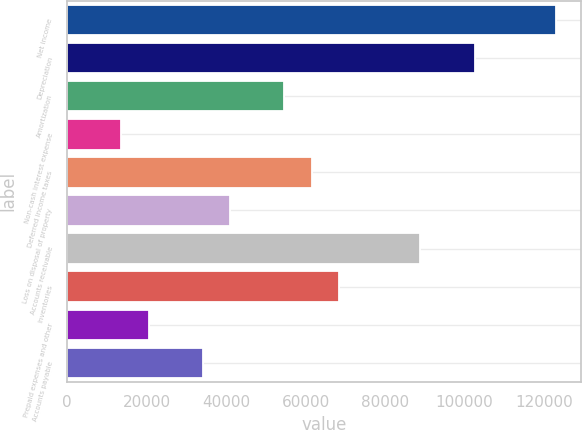Convert chart. <chart><loc_0><loc_0><loc_500><loc_500><bar_chart><fcel>Net income<fcel>Depreciation<fcel>Amortization<fcel>Non-cash interest expense<fcel>Deferred income taxes<fcel>Loss on disposal of property<fcel>Accounts receivable<fcel>Inventories<fcel>Prepaid expenses and other<fcel>Accounts payable<nl><fcel>122985<fcel>102491<fcel>54672.6<fcel>13685.4<fcel>61503.8<fcel>41010.2<fcel>88828.6<fcel>68335<fcel>20516.6<fcel>34179<nl></chart> 